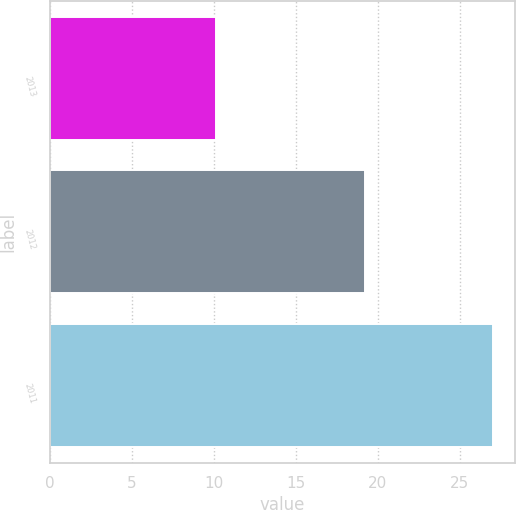Convert chart to OTSL. <chart><loc_0><loc_0><loc_500><loc_500><bar_chart><fcel>2013<fcel>2012<fcel>2011<nl><fcel>10.1<fcel>19.2<fcel>27<nl></chart> 